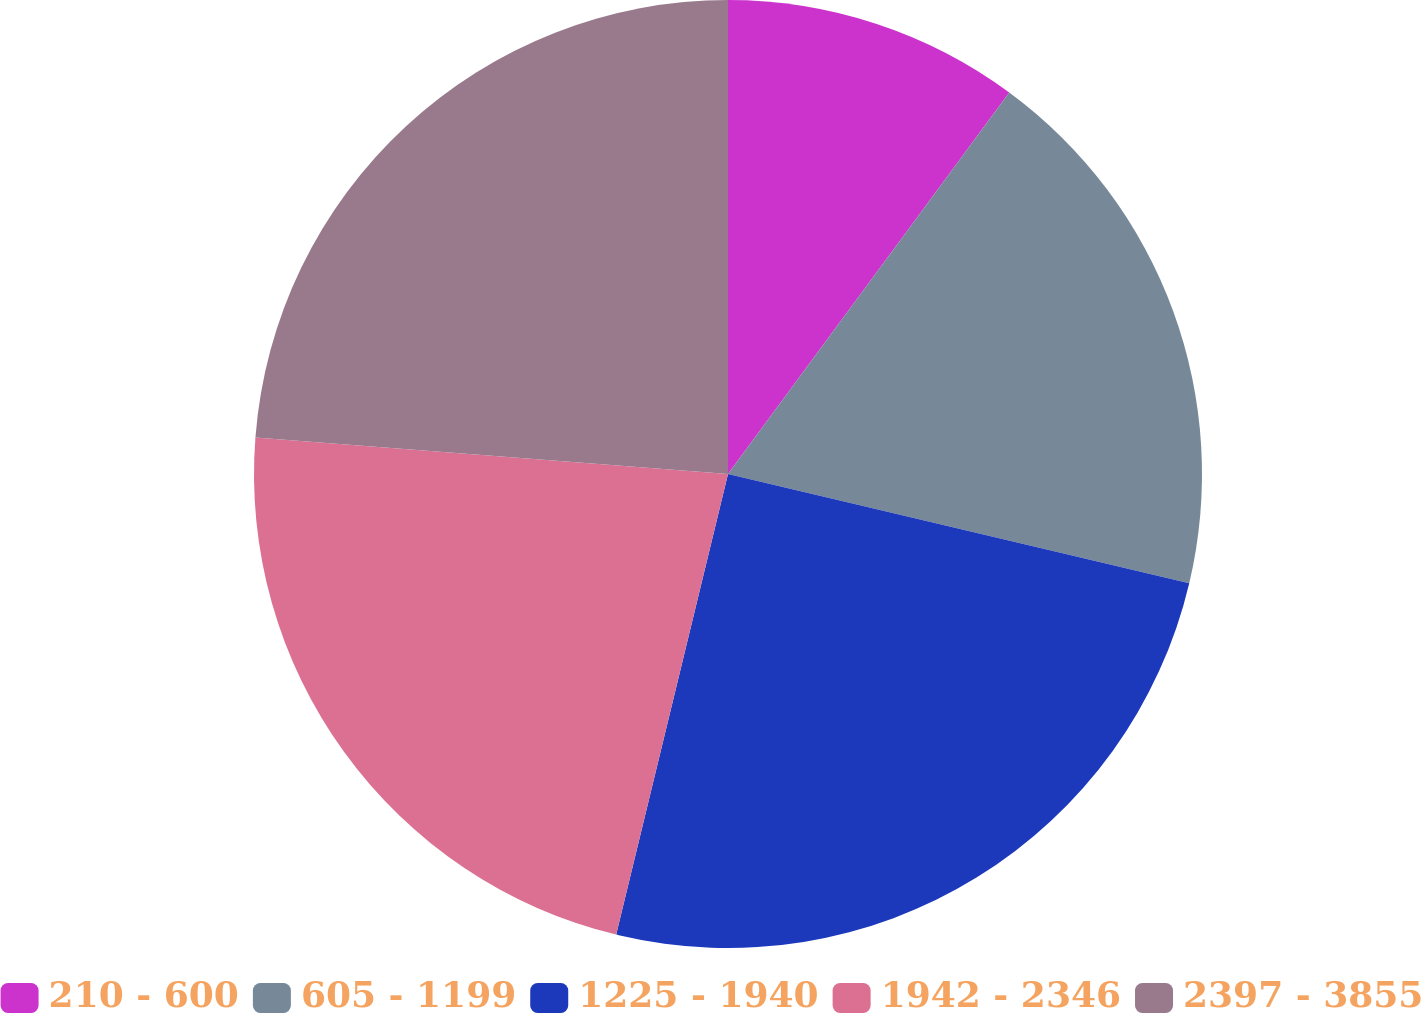Convert chart. <chart><loc_0><loc_0><loc_500><loc_500><pie_chart><fcel>210 - 600<fcel>605 - 1199<fcel>1225 - 1940<fcel>1942 - 2346<fcel>2397 - 3855<nl><fcel>10.11%<fcel>18.59%<fcel>25.09%<fcel>22.44%<fcel>23.77%<nl></chart> 